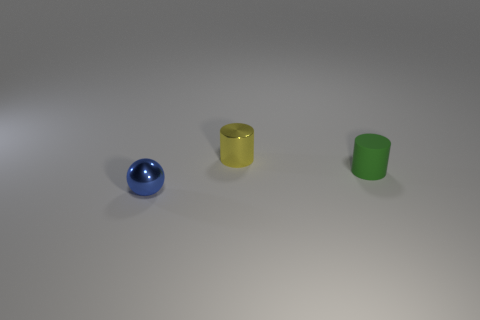Add 3 metallic cylinders. How many objects exist? 6 Subtract all cylinders. How many objects are left? 1 Subtract all yellow cubes. How many yellow cylinders are left? 1 Add 1 tiny blue shiny cubes. How many tiny blue shiny cubes exist? 1 Subtract 0 red balls. How many objects are left? 3 Subtract all cyan spheres. Subtract all green blocks. How many spheres are left? 1 Subtract all blue spheres. Subtract all tiny green things. How many objects are left? 1 Add 2 yellow metal things. How many yellow metal things are left? 3 